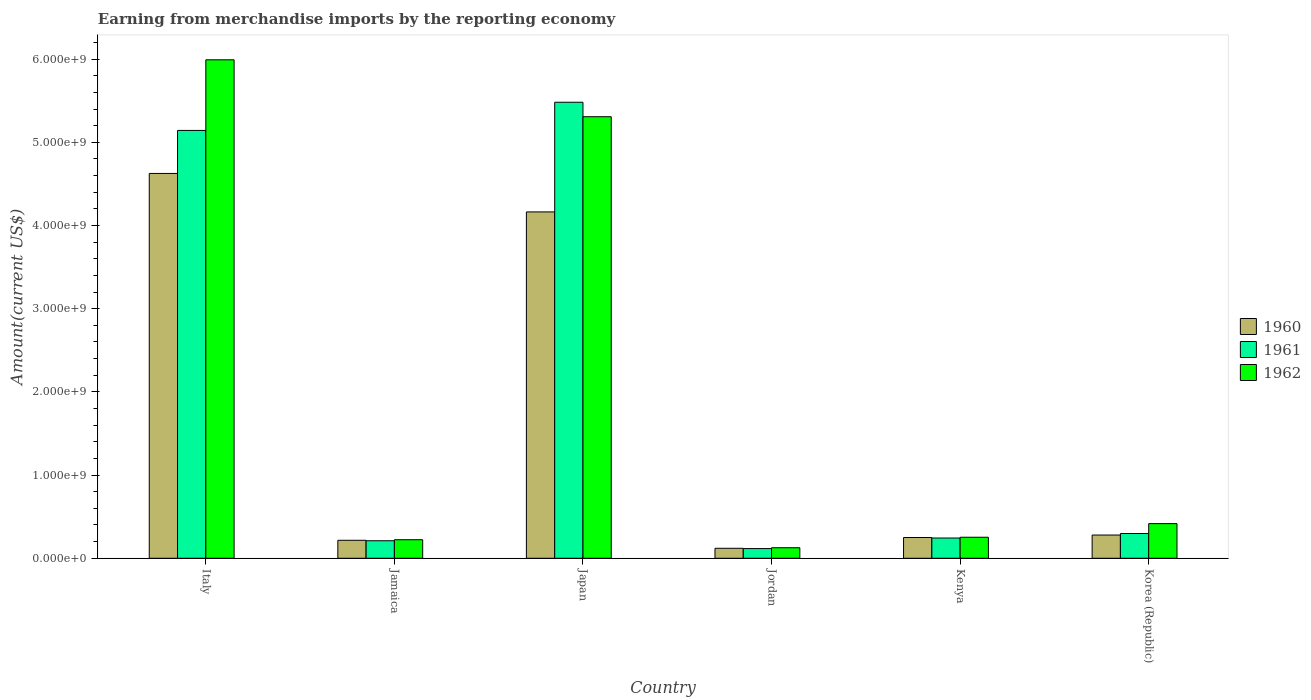How many groups of bars are there?
Offer a terse response. 6. How many bars are there on the 6th tick from the right?
Make the answer very short. 3. What is the label of the 5th group of bars from the left?
Your answer should be very brief. Kenya. In how many cases, is the number of bars for a given country not equal to the number of legend labels?
Your answer should be compact. 0. What is the amount earned from merchandise imports in 1961 in Kenya?
Your answer should be very brief. 2.43e+08. Across all countries, what is the maximum amount earned from merchandise imports in 1961?
Provide a short and direct response. 5.48e+09. Across all countries, what is the minimum amount earned from merchandise imports in 1960?
Provide a short and direct response. 1.20e+08. In which country was the amount earned from merchandise imports in 1961 maximum?
Give a very brief answer. Japan. In which country was the amount earned from merchandise imports in 1962 minimum?
Your response must be concise. Jordan. What is the total amount earned from merchandise imports in 1960 in the graph?
Ensure brevity in your answer.  9.65e+09. What is the difference between the amount earned from merchandise imports in 1961 in Italy and that in Kenya?
Give a very brief answer. 4.90e+09. What is the difference between the amount earned from merchandise imports in 1960 in Jamaica and the amount earned from merchandise imports in 1962 in Japan?
Provide a short and direct response. -5.09e+09. What is the average amount earned from merchandise imports in 1960 per country?
Offer a very short reply. 1.61e+09. What is the difference between the amount earned from merchandise imports of/in 1961 and amount earned from merchandise imports of/in 1962 in Korea (Republic)?
Your answer should be compact. -1.19e+08. In how many countries, is the amount earned from merchandise imports in 1962 greater than 2200000000 US$?
Offer a very short reply. 2. What is the ratio of the amount earned from merchandise imports in 1960 in Jordan to that in Kenya?
Provide a succinct answer. 0.48. Is the amount earned from merchandise imports in 1962 in Jordan less than that in Korea (Republic)?
Keep it short and to the point. Yes. Is the difference between the amount earned from merchandise imports in 1961 in Japan and Jordan greater than the difference between the amount earned from merchandise imports in 1962 in Japan and Jordan?
Ensure brevity in your answer.  Yes. What is the difference between the highest and the second highest amount earned from merchandise imports in 1962?
Your answer should be very brief. 6.84e+08. What is the difference between the highest and the lowest amount earned from merchandise imports in 1962?
Make the answer very short. 5.86e+09. In how many countries, is the amount earned from merchandise imports in 1962 greater than the average amount earned from merchandise imports in 1962 taken over all countries?
Ensure brevity in your answer.  2. What does the 2nd bar from the right in Japan represents?
Make the answer very short. 1961. How many countries are there in the graph?
Provide a short and direct response. 6. What is the difference between two consecutive major ticks on the Y-axis?
Ensure brevity in your answer.  1.00e+09. Does the graph contain grids?
Your answer should be very brief. No. How many legend labels are there?
Your response must be concise. 3. How are the legend labels stacked?
Your answer should be very brief. Vertical. What is the title of the graph?
Provide a short and direct response. Earning from merchandise imports by the reporting economy. What is the label or title of the Y-axis?
Provide a succinct answer. Amount(current US$). What is the Amount(current US$) of 1960 in Italy?
Provide a short and direct response. 4.63e+09. What is the Amount(current US$) in 1961 in Italy?
Your answer should be compact. 5.14e+09. What is the Amount(current US$) in 1962 in Italy?
Make the answer very short. 5.99e+09. What is the Amount(current US$) of 1960 in Jamaica?
Your answer should be compact. 2.16e+08. What is the Amount(current US$) of 1961 in Jamaica?
Give a very brief answer. 2.10e+08. What is the Amount(current US$) in 1962 in Jamaica?
Give a very brief answer. 2.23e+08. What is the Amount(current US$) in 1960 in Japan?
Your answer should be very brief. 4.16e+09. What is the Amount(current US$) of 1961 in Japan?
Your answer should be very brief. 5.48e+09. What is the Amount(current US$) of 1962 in Japan?
Give a very brief answer. 5.31e+09. What is the Amount(current US$) in 1960 in Jordan?
Offer a terse response. 1.20e+08. What is the Amount(current US$) in 1961 in Jordan?
Offer a terse response. 1.16e+08. What is the Amount(current US$) of 1962 in Jordan?
Ensure brevity in your answer.  1.27e+08. What is the Amount(current US$) of 1960 in Kenya?
Ensure brevity in your answer.  2.50e+08. What is the Amount(current US$) in 1961 in Kenya?
Make the answer very short. 2.43e+08. What is the Amount(current US$) of 1962 in Kenya?
Your answer should be very brief. 2.53e+08. What is the Amount(current US$) of 1960 in Korea (Republic)?
Provide a short and direct response. 2.79e+08. What is the Amount(current US$) of 1961 in Korea (Republic)?
Offer a very short reply. 2.97e+08. What is the Amount(current US$) in 1962 in Korea (Republic)?
Provide a succinct answer. 4.16e+08. Across all countries, what is the maximum Amount(current US$) in 1960?
Your answer should be very brief. 4.63e+09. Across all countries, what is the maximum Amount(current US$) in 1961?
Give a very brief answer. 5.48e+09. Across all countries, what is the maximum Amount(current US$) in 1962?
Your answer should be compact. 5.99e+09. Across all countries, what is the minimum Amount(current US$) of 1960?
Provide a short and direct response. 1.20e+08. Across all countries, what is the minimum Amount(current US$) of 1961?
Offer a terse response. 1.16e+08. Across all countries, what is the minimum Amount(current US$) of 1962?
Provide a succinct answer. 1.27e+08. What is the total Amount(current US$) in 1960 in the graph?
Offer a terse response. 9.65e+09. What is the total Amount(current US$) in 1961 in the graph?
Make the answer very short. 1.15e+1. What is the total Amount(current US$) of 1962 in the graph?
Offer a terse response. 1.23e+1. What is the difference between the Amount(current US$) in 1960 in Italy and that in Jamaica?
Provide a succinct answer. 4.41e+09. What is the difference between the Amount(current US$) in 1961 in Italy and that in Jamaica?
Your response must be concise. 4.93e+09. What is the difference between the Amount(current US$) in 1962 in Italy and that in Jamaica?
Your response must be concise. 5.77e+09. What is the difference between the Amount(current US$) in 1960 in Italy and that in Japan?
Your response must be concise. 4.62e+08. What is the difference between the Amount(current US$) of 1961 in Italy and that in Japan?
Your response must be concise. -3.39e+08. What is the difference between the Amount(current US$) of 1962 in Italy and that in Japan?
Provide a succinct answer. 6.84e+08. What is the difference between the Amount(current US$) in 1960 in Italy and that in Jordan?
Make the answer very short. 4.51e+09. What is the difference between the Amount(current US$) of 1961 in Italy and that in Jordan?
Give a very brief answer. 5.03e+09. What is the difference between the Amount(current US$) of 1962 in Italy and that in Jordan?
Ensure brevity in your answer.  5.86e+09. What is the difference between the Amount(current US$) in 1960 in Italy and that in Kenya?
Provide a succinct answer. 4.38e+09. What is the difference between the Amount(current US$) of 1961 in Italy and that in Kenya?
Your response must be concise. 4.90e+09. What is the difference between the Amount(current US$) in 1962 in Italy and that in Kenya?
Give a very brief answer. 5.74e+09. What is the difference between the Amount(current US$) in 1960 in Italy and that in Korea (Republic)?
Your answer should be very brief. 4.35e+09. What is the difference between the Amount(current US$) of 1961 in Italy and that in Korea (Republic)?
Keep it short and to the point. 4.85e+09. What is the difference between the Amount(current US$) in 1962 in Italy and that in Korea (Republic)?
Offer a very short reply. 5.58e+09. What is the difference between the Amount(current US$) of 1960 in Jamaica and that in Japan?
Make the answer very short. -3.95e+09. What is the difference between the Amount(current US$) in 1961 in Jamaica and that in Japan?
Give a very brief answer. -5.27e+09. What is the difference between the Amount(current US$) in 1962 in Jamaica and that in Japan?
Keep it short and to the point. -5.08e+09. What is the difference between the Amount(current US$) in 1960 in Jamaica and that in Jordan?
Your answer should be compact. 9.62e+07. What is the difference between the Amount(current US$) of 1961 in Jamaica and that in Jordan?
Ensure brevity in your answer.  9.39e+07. What is the difference between the Amount(current US$) in 1962 in Jamaica and that in Jordan?
Provide a succinct answer. 9.63e+07. What is the difference between the Amount(current US$) of 1960 in Jamaica and that in Kenya?
Your answer should be compact. -3.35e+07. What is the difference between the Amount(current US$) in 1961 in Jamaica and that in Kenya?
Ensure brevity in your answer.  -3.29e+07. What is the difference between the Amount(current US$) of 1962 in Jamaica and that in Kenya?
Give a very brief answer. -2.98e+07. What is the difference between the Amount(current US$) in 1960 in Jamaica and that in Korea (Republic)?
Your response must be concise. -6.31e+07. What is the difference between the Amount(current US$) of 1961 in Jamaica and that in Korea (Republic)?
Give a very brief answer. -8.70e+07. What is the difference between the Amount(current US$) of 1962 in Jamaica and that in Korea (Republic)?
Your answer should be compact. -1.93e+08. What is the difference between the Amount(current US$) of 1960 in Japan and that in Jordan?
Offer a terse response. 4.04e+09. What is the difference between the Amount(current US$) of 1961 in Japan and that in Jordan?
Ensure brevity in your answer.  5.36e+09. What is the difference between the Amount(current US$) of 1962 in Japan and that in Jordan?
Keep it short and to the point. 5.18e+09. What is the difference between the Amount(current US$) of 1960 in Japan and that in Kenya?
Offer a very short reply. 3.91e+09. What is the difference between the Amount(current US$) of 1961 in Japan and that in Kenya?
Make the answer very short. 5.24e+09. What is the difference between the Amount(current US$) in 1962 in Japan and that in Kenya?
Ensure brevity in your answer.  5.05e+09. What is the difference between the Amount(current US$) of 1960 in Japan and that in Korea (Republic)?
Offer a terse response. 3.88e+09. What is the difference between the Amount(current US$) of 1961 in Japan and that in Korea (Republic)?
Ensure brevity in your answer.  5.18e+09. What is the difference between the Amount(current US$) of 1962 in Japan and that in Korea (Republic)?
Give a very brief answer. 4.89e+09. What is the difference between the Amount(current US$) of 1960 in Jordan and that in Kenya?
Offer a very short reply. -1.30e+08. What is the difference between the Amount(current US$) in 1961 in Jordan and that in Kenya?
Offer a terse response. -1.27e+08. What is the difference between the Amount(current US$) of 1962 in Jordan and that in Kenya?
Offer a terse response. -1.26e+08. What is the difference between the Amount(current US$) in 1960 in Jordan and that in Korea (Republic)?
Offer a very short reply. -1.59e+08. What is the difference between the Amount(current US$) in 1961 in Jordan and that in Korea (Republic)?
Your answer should be very brief. -1.81e+08. What is the difference between the Amount(current US$) in 1962 in Jordan and that in Korea (Republic)?
Provide a succinct answer. -2.90e+08. What is the difference between the Amount(current US$) of 1960 in Kenya and that in Korea (Republic)?
Provide a short and direct response. -2.96e+07. What is the difference between the Amount(current US$) of 1961 in Kenya and that in Korea (Republic)?
Provide a succinct answer. -5.41e+07. What is the difference between the Amount(current US$) of 1962 in Kenya and that in Korea (Republic)?
Offer a very short reply. -1.64e+08. What is the difference between the Amount(current US$) of 1960 in Italy and the Amount(current US$) of 1961 in Jamaica?
Keep it short and to the point. 4.42e+09. What is the difference between the Amount(current US$) in 1960 in Italy and the Amount(current US$) in 1962 in Jamaica?
Provide a short and direct response. 4.40e+09. What is the difference between the Amount(current US$) in 1961 in Italy and the Amount(current US$) in 1962 in Jamaica?
Make the answer very short. 4.92e+09. What is the difference between the Amount(current US$) in 1960 in Italy and the Amount(current US$) in 1961 in Japan?
Keep it short and to the point. -8.56e+08. What is the difference between the Amount(current US$) of 1960 in Italy and the Amount(current US$) of 1962 in Japan?
Make the answer very short. -6.82e+08. What is the difference between the Amount(current US$) of 1961 in Italy and the Amount(current US$) of 1962 in Japan?
Your response must be concise. -1.65e+08. What is the difference between the Amount(current US$) in 1960 in Italy and the Amount(current US$) in 1961 in Jordan?
Your response must be concise. 4.51e+09. What is the difference between the Amount(current US$) of 1960 in Italy and the Amount(current US$) of 1962 in Jordan?
Keep it short and to the point. 4.50e+09. What is the difference between the Amount(current US$) in 1961 in Italy and the Amount(current US$) in 1962 in Jordan?
Your answer should be very brief. 5.02e+09. What is the difference between the Amount(current US$) of 1960 in Italy and the Amount(current US$) of 1961 in Kenya?
Offer a very short reply. 4.38e+09. What is the difference between the Amount(current US$) in 1960 in Italy and the Amount(current US$) in 1962 in Kenya?
Your answer should be very brief. 4.37e+09. What is the difference between the Amount(current US$) of 1961 in Italy and the Amount(current US$) of 1962 in Kenya?
Your answer should be compact. 4.89e+09. What is the difference between the Amount(current US$) of 1960 in Italy and the Amount(current US$) of 1961 in Korea (Republic)?
Offer a terse response. 4.33e+09. What is the difference between the Amount(current US$) in 1960 in Italy and the Amount(current US$) in 1962 in Korea (Republic)?
Your answer should be very brief. 4.21e+09. What is the difference between the Amount(current US$) of 1961 in Italy and the Amount(current US$) of 1962 in Korea (Republic)?
Your answer should be very brief. 4.73e+09. What is the difference between the Amount(current US$) of 1960 in Jamaica and the Amount(current US$) of 1961 in Japan?
Provide a short and direct response. -5.27e+09. What is the difference between the Amount(current US$) in 1960 in Jamaica and the Amount(current US$) in 1962 in Japan?
Ensure brevity in your answer.  -5.09e+09. What is the difference between the Amount(current US$) of 1961 in Jamaica and the Amount(current US$) of 1962 in Japan?
Provide a succinct answer. -5.10e+09. What is the difference between the Amount(current US$) in 1960 in Jamaica and the Amount(current US$) in 1961 in Jordan?
Your response must be concise. 9.96e+07. What is the difference between the Amount(current US$) of 1960 in Jamaica and the Amount(current US$) of 1962 in Jordan?
Make the answer very short. 8.95e+07. What is the difference between the Amount(current US$) in 1961 in Jamaica and the Amount(current US$) in 1962 in Jordan?
Offer a terse response. 8.38e+07. What is the difference between the Amount(current US$) in 1960 in Jamaica and the Amount(current US$) in 1961 in Kenya?
Your answer should be compact. -2.72e+07. What is the difference between the Amount(current US$) in 1960 in Jamaica and the Amount(current US$) in 1962 in Kenya?
Offer a terse response. -3.66e+07. What is the difference between the Amount(current US$) of 1961 in Jamaica and the Amount(current US$) of 1962 in Kenya?
Your answer should be compact. -4.23e+07. What is the difference between the Amount(current US$) in 1960 in Jamaica and the Amount(current US$) in 1961 in Korea (Republic)?
Give a very brief answer. -8.13e+07. What is the difference between the Amount(current US$) in 1960 in Jamaica and the Amount(current US$) in 1962 in Korea (Republic)?
Offer a terse response. -2.00e+08. What is the difference between the Amount(current US$) in 1961 in Jamaica and the Amount(current US$) in 1962 in Korea (Republic)?
Offer a terse response. -2.06e+08. What is the difference between the Amount(current US$) of 1960 in Japan and the Amount(current US$) of 1961 in Jordan?
Offer a terse response. 4.05e+09. What is the difference between the Amount(current US$) in 1960 in Japan and the Amount(current US$) in 1962 in Jordan?
Offer a terse response. 4.04e+09. What is the difference between the Amount(current US$) of 1961 in Japan and the Amount(current US$) of 1962 in Jordan?
Give a very brief answer. 5.35e+09. What is the difference between the Amount(current US$) in 1960 in Japan and the Amount(current US$) in 1961 in Kenya?
Provide a short and direct response. 3.92e+09. What is the difference between the Amount(current US$) in 1960 in Japan and the Amount(current US$) in 1962 in Kenya?
Your answer should be very brief. 3.91e+09. What is the difference between the Amount(current US$) in 1961 in Japan and the Amount(current US$) in 1962 in Kenya?
Provide a short and direct response. 5.23e+09. What is the difference between the Amount(current US$) in 1960 in Japan and the Amount(current US$) in 1961 in Korea (Republic)?
Your response must be concise. 3.87e+09. What is the difference between the Amount(current US$) of 1960 in Japan and the Amount(current US$) of 1962 in Korea (Republic)?
Provide a succinct answer. 3.75e+09. What is the difference between the Amount(current US$) in 1961 in Japan and the Amount(current US$) in 1962 in Korea (Republic)?
Provide a short and direct response. 5.07e+09. What is the difference between the Amount(current US$) of 1960 in Jordan and the Amount(current US$) of 1961 in Kenya?
Offer a very short reply. -1.23e+08. What is the difference between the Amount(current US$) in 1960 in Jordan and the Amount(current US$) in 1962 in Kenya?
Your response must be concise. -1.33e+08. What is the difference between the Amount(current US$) in 1961 in Jordan and the Amount(current US$) in 1962 in Kenya?
Your response must be concise. -1.36e+08. What is the difference between the Amount(current US$) of 1960 in Jordan and the Amount(current US$) of 1961 in Korea (Republic)?
Your answer should be very brief. -1.78e+08. What is the difference between the Amount(current US$) in 1960 in Jordan and the Amount(current US$) in 1962 in Korea (Republic)?
Provide a short and direct response. -2.96e+08. What is the difference between the Amount(current US$) of 1961 in Jordan and the Amount(current US$) of 1962 in Korea (Republic)?
Your response must be concise. -3.00e+08. What is the difference between the Amount(current US$) of 1960 in Kenya and the Amount(current US$) of 1961 in Korea (Republic)?
Offer a terse response. -4.78e+07. What is the difference between the Amount(current US$) in 1960 in Kenya and the Amount(current US$) in 1962 in Korea (Republic)?
Make the answer very short. -1.67e+08. What is the difference between the Amount(current US$) of 1961 in Kenya and the Amount(current US$) of 1962 in Korea (Republic)?
Your response must be concise. -1.73e+08. What is the average Amount(current US$) of 1960 per country?
Provide a short and direct response. 1.61e+09. What is the average Amount(current US$) of 1961 per country?
Offer a very short reply. 1.92e+09. What is the average Amount(current US$) of 1962 per country?
Ensure brevity in your answer.  2.05e+09. What is the difference between the Amount(current US$) in 1960 and Amount(current US$) in 1961 in Italy?
Your answer should be compact. -5.17e+08. What is the difference between the Amount(current US$) of 1960 and Amount(current US$) of 1962 in Italy?
Give a very brief answer. -1.37e+09. What is the difference between the Amount(current US$) of 1961 and Amount(current US$) of 1962 in Italy?
Keep it short and to the point. -8.49e+08. What is the difference between the Amount(current US$) of 1960 and Amount(current US$) of 1961 in Jamaica?
Provide a short and direct response. 5.70e+06. What is the difference between the Amount(current US$) in 1960 and Amount(current US$) in 1962 in Jamaica?
Offer a very short reply. -6.80e+06. What is the difference between the Amount(current US$) in 1961 and Amount(current US$) in 1962 in Jamaica?
Offer a terse response. -1.25e+07. What is the difference between the Amount(current US$) in 1960 and Amount(current US$) in 1961 in Japan?
Offer a terse response. -1.32e+09. What is the difference between the Amount(current US$) in 1960 and Amount(current US$) in 1962 in Japan?
Your response must be concise. -1.14e+09. What is the difference between the Amount(current US$) of 1961 and Amount(current US$) of 1962 in Japan?
Ensure brevity in your answer.  1.74e+08. What is the difference between the Amount(current US$) in 1960 and Amount(current US$) in 1961 in Jordan?
Your response must be concise. 3.40e+06. What is the difference between the Amount(current US$) in 1960 and Amount(current US$) in 1962 in Jordan?
Provide a short and direct response. -6.70e+06. What is the difference between the Amount(current US$) in 1961 and Amount(current US$) in 1962 in Jordan?
Offer a very short reply. -1.01e+07. What is the difference between the Amount(current US$) of 1960 and Amount(current US$) of 1961 in Kenya?
Offer a very short reply. 6.30e+06. What is the difference between the Amount(current US$) of 1960 and Amount(current US$) of 1962 in Kenya?
Offer a very short reply. -3.10e+06. What is the difference between the Amount(current US$) in 1961 and Amount(current US$) in 1962 in Kenya?
Provide a succinct answer. -9.40e+06. What is the difference between the Amount(current US$) in 1960 and Amount(current US$) in 1961 in Korea (Republic)?
Ensure brevity in your answer.  -1.82e+07. What is the difference between the Amount(current US$) in 1960 and Amount(current US$) in 1962 in Korea (Republic)?
Offer a terse response. -1.37e+08. What is the difference between the Amount(current US$) of 1961 and Amount(current US$) of 1962 in Korea (Republic)?
Offer a terse response. -1.19e+08. What is the ratio of the Amount(current US$) of 1960 in Italy to that in Jamaica?
Give a very brief answer. 21.4. What is the ratio of the Amount(current US$) of 1961 in Italy to that in Jamaica?
Keep it short and to the point. 24.44. What is the ratio of the Amount(current US$) of 1962 in Italy to that in Jamaica?
Your answer should be compact. 26.88. What is the ratio of the Amount(current US$) in 1960 in Italy to that in Japan?
Offer a very short reply. 1.11. What is the ratio of the Amount(current US$) of 1961 in Italy to that in Japan?
Your answer should be very brief. 0.94. What is the ratio of the Amount(current US$) of 1962 in Italy to that in Japan?
Provide a succinct answer. 1.13. What is the ratio of the Amount(current US$) of 1960 in Italy to that in Jordan?
Offer a terse response. 38.58. What is the ratio of the Amount(current US$) of 1961 in Italy to that in Jordan?
Your answer should be compact. 44.14. What is the ratio of the Amount(current US$) of 1962 in Italy to that in Jordan?
Provide a short and direct response. 47.33. What is the ratio of the Amount(current US$) of 1960 in Italy to that in Kenya?
Make the answer very short. 18.53. What is the ratio of the Amount(current US$) in 1961 in Italy to that in Kenya?
Give a very brief answer. 21.14. What is the ratio of the Amount(current US$) in 1962 in Italy to that in Kenya?
Your response must be concise. 23.71. What is the ratio of the Amount(current US$) in 1960 in Italy to that in Korea (Republic)?
Make the answer very short. 16.57. What is the ratio of the Amount(current US$) in 1961 in Italy to that in Korea (Republic)?
Give a very brief answer. 17.29. What is the ratio of the Amount(current US$) in 1962 in Italy to that in Korea (Republic)?
Give a very brief answer. 14.39. What is the ratio of the Amount(current US$) in 1960 in Jamaica to that in Japan?
Provide a succinct answer. 0.05. What is the ratio of the Amount(current US$) in 1961 in Jamaica to that in Japan?
Ensure brevity in your answer.  0.04. What is the ratio of the Amount(current US$) in 1962 in Jamaica to that in Japan?
Provide a short and direct response. 0.04. What is the ratio of the Amount(current US$) of 1960 in Jamaica to that in Jordan?
Offer a very short reply. 1.8. What is the ratio of the Amount(current US$) of 1961 in Jamaica to that in Jordan?
Keep it short and to the point. 1.81. What is the ratio of the Amount(current US$) in 1962 in Jamaica to that in Jordan?
Keep it short and to the point. 1.76. What is the ratio of the Amount(current US$) of 1960 in Jamaica to that in Kenya?
Keep it short and to the point. 0.87. What is the ratio of the Amount(current US$) in 1961 in Jamaica to that in Kenya?
Ensure brevity in your answer.  0.86. What is the ratio of the Amount(current US$) in 1962 in Jamaica to that in Kenya?
Offer a terse response. 0.88. What is the ratio of the Amount(current US$) of 1960 in Jamaica to that in Korea (Republic)?
Ensure brevity in your answer.  0.77. What is the ratio of the Amount(current US$) of 1961 in Jamaica to that in Korea (Republic)?
Keep it short and to the point. 0.71. What is the ratio of the Amount(current US$) in 1962 in Jamaica to that in Korea (Republic)?
Your answer should be very brief. 0.54. What is the ratio of the Amount(current US$) in 1960 in Japan to that in Jordan?
Offer a terse response. 34.72. What is the ratio of the Amount(current US$) in 1961 in Japan to that in Jordan?
Your answer should be very brief. 47.05. What is the ratio of the Amount(current US$) in 1962 in Japan to that in Jordan?
Give a very brief answer. 41.92. What is the ratio of the Amount(current US$) of 1960 in Japan to that in Kenya?
Offer a very short reply. 16.68. What is the ratio of the Amount(current US$) of 1961 in Japan to that in Kenya?
Provide a short and direct response. 22.53. What is the ratio of the Amount(current US$) in 1962 in Japan to that in Kenya?
Ensure brevity in your answer.  21. What is the ratio of the Amount(current US$) of 1960 in Japan to that in Korea (Republic)?
Ensure brevity in your answer.  14.91. What is the ratio of the Amount(current US$) in 1961 in Japan to that in Korea (Republic)?
Offer a very short reply. 18.43. What is the ratio of the Amount(current US$) in 1962 in Japan to that in Korea (Republic)?
Your answer should be very brief. 12.75. What is the ratio of the Amount(current US$) in 1960 in Jordan to that in Kenya?
Keep it short and to the point. 0.48. What is the ratio of the Amount(current US$) in 1961 in Jordan to that in Kenya?
Make the answer very short. 0.48. What is the ratio of the Amount(current US$) in 1962 in Jordan to that in Kenya?
Keep it short and to the point. 0.5. What is the ratio of the Amount(current US$) of 1960 in Jordan to that in Korea (Republic)?
Your answer should be very brief. 0.43. What is the ratio of the Amount(current US$) of 1961 in Jordan to that in Korea (Republic)?
Ensure brevity in your answer.  0.39. What is the ratio of the Amount(current US$) of 1962 in Jordan to that in Korea (Republic)?
Make the answer very short. 0.3. What is the ratio of the Amount(current US$) of 1960 in Kenya to that in Korea (Republic)?
Keep it short and to the point. 0.89. What is the ratio of the Amount(current US$) in 1961 in Kenya to that in Korea (Republic)?
Offer a terse response. 0.82. What is the ratio of the Amount(current US$) in 1962 in Kenya to that in Korea (Republic)?
Make the answer very short. 0.61. What is the difference between the highest and the second highest Amount(current US$) of 1960?
Your answer should be compact. 4.62e+08. What is the difference between the highest and the second highest Amount(current US$) of 1961?
Give a very brief answer. 3.39e+08. What is the difference between the highest and the second highest Amount(current US$) of 1962?
Your answer should be very brief. 6.84e+08. What is the difference between the highest and the lowest Amount(current US$) of 1960?
Give a very brief answer. 4.51e+09. What is the difference between the highest and the lowest Amount(current US$) in 1961?
Make the answer very short. 5.36e+09. What is the difference between the highest and the lowest Amount(current US$) of 1962?
Your answer should be compact. 5.86e+09. 